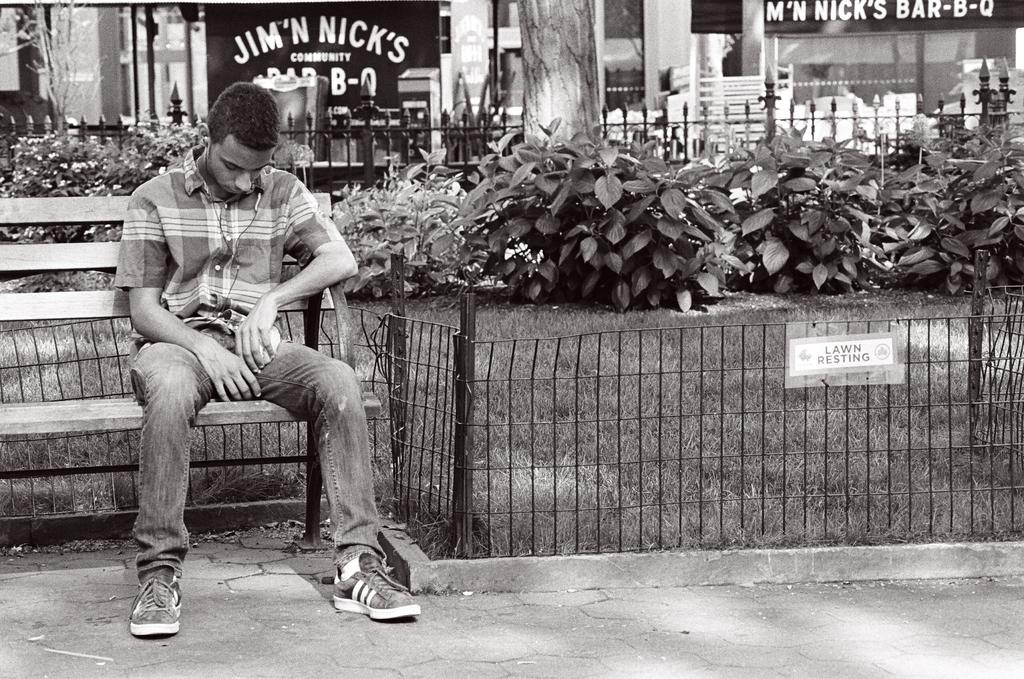What is the man in the image doing? The man is sitting on a bench in the image. Where was the image taken? The image was taken outside. What can be seen in the background of the image? There are plants, grass, and trees in the background of the image. What type of gun is the man holding in the image? There is no gun present in the image; the man is simply sitting on a bench. 